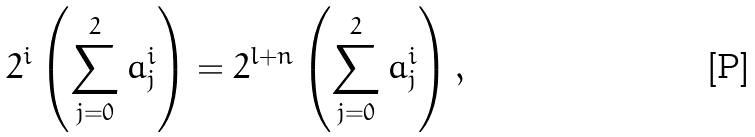<formula> <loc_0><loc_0><loc_500><loc_500>2 ^ { i } \left ( \sum _ { j = 0 } ^ { 2 } a ^ { i } _ { j } \right ) = 2 ^ { l + n } \left ( \sum _ { j = 0 } ^ { 2 } a ^ { i } _ { j } \right ) ,</formula> 